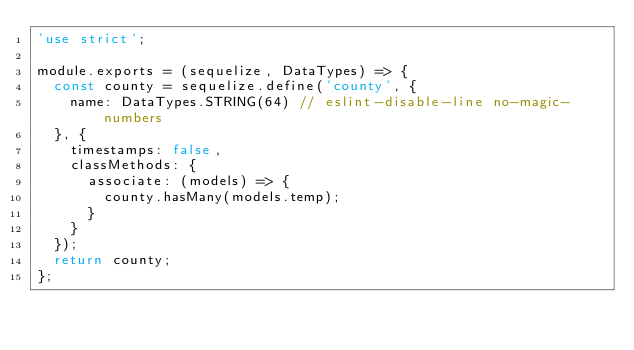Convert code to text. <code><loc_0><loc_0><loc_500><loc_500><_JavaScript_>'use strict';

module.exports = (sequelize, DataTypes) => {
  const county = sequelize.define('county', {
    name: DataTypes.STRING(64) // eslint-disable-line no-magic-numbers
  }, {
    timestamps: false,
    classMethods: {
      associate: (models) => {
        county.hasMany(models.temp);
      }
    }
  });
  return county;
};
</code> 